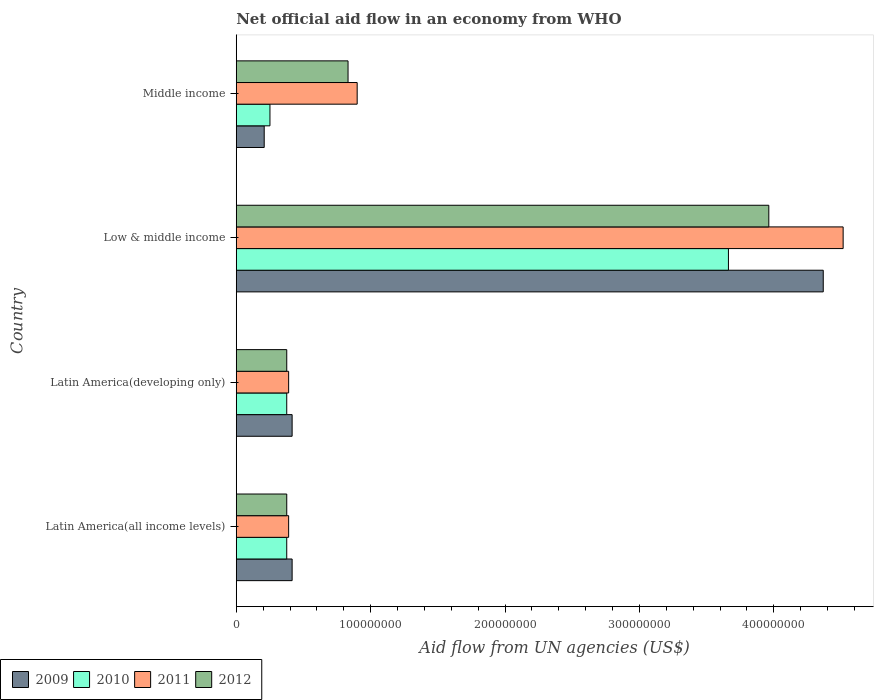How many different coloured bars are there?
Provide a short and direct response. 4. How many groups of bars are there?
Your answer should be very brief. 4. Are the number of bars per tick equal to the number of legend labels?
Keep it short and to the point. Yes. Are the number of bars on each tick of the Y-axis equal?
Keep it short and to the point. Yes. What is the label of the 4th group of bars from the top?
Your answer should be very brief. Latin America(all income levels). In how many cases, is the number of bars for a given country not equal to the number of legend labels?
Make the answer very short. 0. What is the net official aid flow in 2010 in Latin America(all income levels)?
Provide a succinct answer. 3.76e+07. Across all countries, what is the maximum net official aid flow in 2011?
Ensure brevity in your answer.  4.52e+08. Across all countries, what is the minimum net official aid flow in 2009?
Offer a very short reply. 2.08e+07. In which country was the net official aid flow in 2011 minimum?
Your answer should be compact. Latin America(all income levels). What is the total net official aid flow in 2009 in the graph?
Provide a short and direct response. 5.41e+08. What is the difference between the net official aid flow in 2009 in Latin America(all income levels) and that in Low & middle income?
Offer a terse response. -3.95e+08. What is the difference between the net official aid flow in 2009 in Latin America(all income levels) and the net official aid flow in 2010 in Middle income?
Ensure brevity in your answer.  1.65e+07. What is the average net official aid flow in 2011 per country?
Give a very brief answer. 1.55e+08. What is the difference between the net official aid flow in 2011 and net official aid flow in 2010 in Latin America(developing only)?
Give a very brief answer. 1.42e+06. What is the ratio of the net official aid flow in 2011 in Latin America(all income levels) to that in Latin America(developing only)?
Give a very brief answer. 1. Is the net official aid flow in 2010 in Latin America(developing only) less than that in Low & middle income?
Your answer should be very brief. Yes. Is the difference between the net official aid flow in 2011 in Low & middle income and Middle income greater than the difference between the net official aid flow in 2010 in Low & middle income and Middle income?
Your answer should be very brief. Yes. What is the difference between the highest and the second highest net official aid flow in 2009?
Keep it short and to the point. 3.95e+08. What is the difference between the highest and the lowest net official aid flow in 2012?
Ensure brevity in your answer.  3.59e+08. In how many countries, is the net official aid flow in 2009 greater than the average net official aid flow in 2009 taken over all countries?
Ensure brevity in your answer.  1. Is the sum of the net official aid flow in 2012 in Low & middle income and Middle income greater than the maximum net official aid flow in 2010 across all countries?
Keep it short and to the point. Yes. What does the 2nd bar from the bottom in Middle income represents?
Offer a terse response. 2010. How many bars are there?
Keep it short and to the point. 16. Are all the bars in the graph horizontal?
Provide a short and direct response. Yes. What is the difference between two consecutive major ticks on the X-axis?
Give a very brief answer. 1.00e+08. Does the graph contain grids?
Ensure brevity in your answer.  No. Where does the legend appear in the graph?
Ensure brevity in your answer.  Bottom left. What is the title of the graph?
Your answer should be compact. Net official aid flow in an economy from WHO. Does "1980" appear as one of the legend labels in the graph?
Your response must be concise. No. What is the label or title of the X-axis?
Your response must be concise. Aid flow from UN agencies (US$). What is the label or title of the Y-axis?
Make the answer very short. Country. What is the Aid flow from UN agencies (US$) in 2009 in Latin America(all income levels)?
Offer a very short reply. 4.16e+07. What is the Aid flow from UN agencies (US$) of 2010 in Latin America(all income levels)?
Ensure brevity in your answer.  3.76e+07. What is the Aid flow from UN agencies (US$) of 2011 in Latin America(all income levels)?
Your answer should be very brief. 3.90e+07. What is the Aid flow from UN agencies (US$) in 2012 in Latin America(all income levels)?
Offer a terse response. 3.76e+07. What is the Aid flow from UN agencies (US$) in 2009 in Latin America(developing only)?
Your response must be concise. 4.16e+07. What is the Aid flow from UN agencies (US$) in 2010 in Latin America(developing only)?
Ensure brevity in your answer.  3.76e+07. What is the Aid flow from UN agencies (US$) of 2011 in Latin America(developing only)?
Your response must be concise. 3.90e+07. What is the Aid flow from UN agencies (US$) of 2012 in Latin America(developing only)?
Provide a short and direct response. 3.76e+07. What is the Aid flow from UN agencies (US$) in 2009 in Low & middle income?
Your response must be concise. 4.37e+08. What is the Aid flow from UN agencies (US$) of 2010 in Low & middle income?
Provide a succinct answer. 3.66e+08. What is the Aid flow from UN agencies (US$) of 2011 in Low & middle income?
Keep it short and to the point. 4.52e+08. What is the Aid flow from UN agencies (US$) in 2012 in Low & middle income?
Offer a very short reply. 3.96e+08. What is the Aid flow from UN agencies (US$) in 2009 in Middle income?
Give a very brief answer. 2.08e+07. What is the Aid flow from UN agencies (US$) in 2010 in Middle income?
Your answer should be very brief. 2.51e+07. What is the Aid flow from UN agencies (US$) in 2011 in Middle income?
Give a very brief answer. 9.00e+07. What is the Aid flow from UN agencies (US$) of 2012 in Middle income?
Offer a very short reply. 8.32e+07. Across all countries, what is the maximum Aid flow from UN agencies (US$) in 2009?
Provide a succinct answer. 4.37e+08. Across all countries, what is the maximum Aid flow from UN agencies (US$) of 2010?
Give a very brief answer. 3.66e+08. Across all countries, what is the maximum Aid flow from UN agencies (US$) in 2011?
Offer a very short reply. 4.52e+08. Across all countries, what is the maximum Aid flow from UN agencies (US$) in 2012?
Offer a terse response. 3.96e+08. Across all countries, what is the minimum Aid flow from UN agencies (US$) of 2009?
Provide a short and direct response. 2.08e+07. Across all countries, what is the minimum Aid flow from UN agencies (US$) in 2010?
Make the answer very short. 2.51e+07. Across all countries, what is the minimum Aid flow from UN agencies (US$) in 2011?
Make the answer very short. 3.90e+07. Across all countries, what is the minimum Aid flow from UN agencies (US$) in 2012?
Your answer should be very brief. 3.76e+07. What is the total Aid flow from UN agencies (US$) in 2009 in the graph?
Your response must be concise. 5.41e+08. What is the total Aid flow from UN agencies (US$) of 2010 in the graph?
Your answer should be compact. 4.66e+08. What is the total Aid flow from UN agencies (US$) in 2011 in the graph?
Keep it short and to the point. 6.20e+08. What is the total Aid flow from UN agencies (US$) of 2012 in the graph?
Give a very brief answer. 5.55e+08. What is the difference between the Aid flow from UN agencies (US$) of 2009 in Latin America(all income levels) and that in Latin America(developing only)?
Keep it short and to the point. 0. What is the difference between the Aid flow from UN agencies (US$) of 2010 in Latin America(all income levels) and that in Latin America(developing only)?
Your answer should be compact. 0. What is the difference between the Aid flow from UN agencies (US$) of 2009 in Latin America(all income levels) and that in Low & middle income?
Your response must be concise. -3.95e+08. What is the difference between the Aid flow from UN agencies (US$) in 2010 in Latin America(all income levels) and that in Low & middle income?
Offer a very short reply. -3.29e+08. What is the difference between the Aid flow from UN agencies (US$) of 2011 in Latin America(all income levels) and that in Low & middle income?
Keep it short and to the point. -4.13e+08. What is the difference between the Aid flow from UN agencies (US$) of 2012 in Latin America(all income levels) and that in Low & middle income?
Give a very brief answer. -3.59e+08. What is the difference between the Aid flow from UN agencies (US$) of 2009 in Latin America(all income levels) and that in Middle income?
Give a very brief answer. 2.08e+07. What is the difference between the Aid flow from UN agencies (US$) in 2010 in Latin America(all income levels) and that in Middle income?
Ensure brevity in your answer.  1.25e+07. What is the difference between the Aid flow from UN agencies (US$) of 2011 in Latin America(all income levels) and that in Middle income?
Make the answer very short. -5.10e+07. What is the difference between the Aid flow from UN agencies (US$) in 2012 in Latin America(all income levels) and that in Middle income?
Ensure brevity in your answer.  -4.56e+07. What is the difference between the Aid flow from UN agencies (US$) in 2009 in Latin America(developing only) and that in Low & middle income?
Your response must be concise. -3.95e+08. What is the difference between the Aid flow from UN agencies (US$) of 2010 in Latin America(developing only) and that in Low & middle income?
Provide a short and direct response. -3.29e+08. What is the difference between the Aid flow from UN agencies (US$) of 2011 in Latin America(developing only) and that in Low & middle income?
Your answer should be very brief. -4.13e+08. What is the difference between the Aid flow from UN agencies (US$) in 2012 in Latin America(developing only) and that in Low & middle income?
Make the answer very short. -3.59e+08. What is the difference between the Aid flow from UN agencies (US$) in 2009 in Latin America(developing only) and that in Middle income?
Ensure brevity in your answer.  2.08e+07. What is the difference between the Aid flow from UN agencies (US$) of 2010 in Latin America(developing only) and that in Middle income?
Offer a terse response. 1.25e+07. What is the difference between the Aid flow from UN agencies (US$) of 2011 in Latin America(developing only) and that in Middle income?
Ensure brevity in your answer.  -5.10e+07. What is the difference between the Aid flow from UN agencies (US$) in 2012 in Latin America(developing only) and that in Middle income?
Keep it short and to the point. -4.56e+07. What is the difference between the Aid flow from UN agencies (US$) of 2009 in Low & middle income and that in Middle income?
Offer a terse response. 4.16e+08. What is the difference between the Aid flow from UN agencies (US$) in 2010 in Low & middle income and that in Middle income?
Keep it short and to the point. 3.41e+08. What is the difference between the Aid flow from UN agencies (US$) in 2011 in Low & middle income and that in Middle income?
Your answer should be compact. 3.62e+08. What is the difference between the Aid flow from UN agencies (US$) in 2012 in Low & middle income and that in Middle income?
Ensure brevity in your answer.  3.13e+08. What is the difference between the Aid flow from UN agencies (US$) in 2009 in Latin America(all income levels) and the Aid flow from UN agencies (US$) in 2010 in Latin America(developing only)?
Offer a terse response. 4.01e+06. What is the difference between the Aid flow from UN agencies (US$) in 2009 in Latin America(all income levels) and the Aid flow from UN agencies (US$) in 2011 in Latin America(developing only)?
Make the answer very short. 2.59e+06. What is the difference between the Aid flow from UN agencies (US$) in 2009 in Latin America(all income levels) and the Aid flow from UN agencies (US$) in 2012 in Latin America(developing only)?
Offer a terse response. 3.99e+06. What is the difference between the Aid flow from UN agencies (US$) in 2010 in Latin America(all income levels) and the Aid flow from UN agencies (US$) in 2011 in Latin America(developing only)?
Offer a terse response. -1.42e+06. What is the difference between the Aid flow from UN agencies (US$) of 2010 in Latin America(all income levels) and the Aid flow from UN agencies (US$) of 2012 in Latin America(developing only)?
Your answer should be very brief. -2.00e+04. What is the difference between the Aid flow from UN agencies (US$) in 2011 in Latin America(all income levels) and the Aid flow from UN agencies (US$) in 2012 in Latin America(developing only)?
Your response must be concise. 1.40e+06. What is the difference between the Aid flow from UN agencies (US$) in 2009 in Latin America(all income levels) and the Aid flow from UN agencies (US$) in 2010 in Low & middle income?
Keep it short and to the point. -3.25e+08. What is the difference between the Aid flow from UN agencies (US$) in 2009 in Latin America(all income levels) and the Aid flow from UN agencies (US$) in 2011 in Low & middle income?
Your answer should be compact. -4.10e+08. What is the difference between the Aid flow from UN agencies (US$) in 2009 in Latin America(all income levels) and the Aid flow from UN agencies (US$) in 2012 in Low & middle income?
Your answer should be very brief. -3.55e+08. What is the difference between the Aid flow from UN agencies (US$) of 2010 in Latin America(all income levels) and the Aid flow from UN agencies (US$) of 2011 in Low & middle income?
Offer a terse response. -4.14e+08. What is the difference between the Aid flow from UN agencies (US$) of 2010 in Latin America(all income levels) and the Aid flow from UN agencies (US$) of 2012 in Low & middle income?
Keep it short and to the point. -3.59e+08. What is the difference between the Aid flow from UN agencies (US$) of 2011 in Latin America(all income levels) and the Aid flow from UN agencies (US$) of 2012 in Low & middle income?
Provide a succinct answer. -3.57e+08. What is the difference between the Aid flow from UN agencies (US$) of 2009 in Latin America(all income levels) and the Aid flow from UN agencies (US$) of 2010 in Middle income?
Offer a terse response. 1.65e+07. What is the difference between the Aid flow from UN agencies (US$) of 2009 in Latin America(all income levels) and the Aid flow from UN agencies (US$) of 2011 in Middle income?
Ensure brevity in your answer.  -4.84e+07. What is the difference between the Aid flow from UN agencies (US$) of 2009 in Latin America(all income levels) and the Aid flow from UN agencies (US$) of 2012 in Middle income?
Your response must be concise. -4.16e+07. What is the difference between the Aid flow from UN agencies (US$) of 2010 in Latin America(all income levels) and the Aid flow from UN agencies (US$) of 2011 in Middle income?
Your response must be concise. -5.24e+07. What is the difference between the Aid flow from UN agencies (US$) in 2010 in Latin America(all income levels) and the Aid flow from UN agencies (US$) in 2012 in Middle income?
Your response must be concise. -4.56e+07. What is the difference between the Aid flow from UN agencies (US$) of 2011 in Latin America(all income levels) and the Aid flow from UN agencies (US$) of 2012 in Middle income?
Ensure brevity in your answer.  -4.42e+07. What is the difference between the Aid flow from UN agencies (US$) of 2009 in Latin America(developing only) and the Aid flow from UN agencies (US$) of 2010 in Low & middle income?
Offer a very short reply. -3.25e+08. What is the difference between the Aid flow from UN agencies (US$) of 2009 in Latin America(developing only) and the Aid flow from UN agencies (US$) of 2011 in Low & middle income?
Ensure brevity in your answer.  -4.10e+08. What is the difference between the Aid flow from UN agencies (US$) in 2009 in Latin America(developing only) and the Aid flow from UN agencies (US$) in 2012 in Low & middle income?
Keep it short and to the point. -3.55e+08. What is the difference between the Aid flow from UN agencies (US$) in 2010 in Latin America(developing only) and the Aid flow from UN agencies (US$) in 2011 in Low & middle income?
Offer a terse response. -4.14e+08. What is the difference between the Aid flow from UN agencies (US$) in 2010 in Latin America(developing only) and the Aid flow from UN agencies (US$) in 2012 in Low & middle income?
Offer a terse response. -3.59e+08. What is the difference between the Aid flow from UN agencies (US$) in 2011 in Latin America(developing only) and the Aid flow from UN agencies (US$) in 2012 in Low & middle income?
Your response must be concise. -3.57e+08. What is the difference between the Aid flow from UN agencies (US$) in 2009 in Latin America(developing only) and the Aid flow from UN agencies (US$) in 2010 in Middle income?
Your answer should be very brief. 1.65e+07. What is the difference between the Aid flow from UN agencies (US$) in 2009 in Latin America(developing only) and the Aid flow from UN agencies (US$) in 2011 in Middle income?
Your answer should be very brief. -4.84e+07. What is the difference between the Aid flow from UN agencies (US$) in 2009 in Latin America(developing only) and the Aid flow from UN agencies (US$) in 2012 in Middle income?
Provide a short and direct response. -4.16e+07. What is the difference between the Aid flow from UN agencies (US$) of 2010 in Latin America(developing only) and the Aid flow from UN agencies (US$) of 2011 in Middle income?
Your response must be concise. -5.24e+07. What is the difference between the Aid flow from UN agencies (US$) of 2010 in Latin America(developing only) and the Aid flow from UN agencies (US$) of 2012 in Middle income?
Offer a terse response. -4.56e+07. What is the difference between the Aid flow from UN agencies (US$) in 2011 in Latin America(developing only) and the Aid flow from UN agencies (US$) in 2012 in Middle income?
Your answer should be compact. -4.42e+07. What is the difference between the Aid flow from UN agencies (US$) of 2009 in Low & middle income and the Aid flow from UN agencies (US$) of 2010 in Middle income?
Make the answer very short. 4.12e+08. What is the difference between the Aid flow from UN agencies (US$) of 2009 in Low & middle income and the Aid flow from UN agencies (US$) of 2011 in Middle income?
Make the answer very short. 3.47e+08. What is the difference between the Aid flow from UN agencies (US$) of 2009 in Low & middle income and the Aid flow from UN agencies (US$) of 2012 in Middle income?
Offer a terse response. 3.54e+08. What is the difference between the Aid flow from UN agencies (US$) in 2010 in Low & middle income and the Aid flow from UN agencies (US$) in 2011 in Middle income?
Your answer should be compact. 2.76e+08. What is the difference between the Aid flow from UN agencies (US$) in 2010 in Low & middle income and the Aid flow from UN agencies (US$) in 2012 in Middle income?
Provide a short and direct response. 2.83e+08. What is the difference between the Aid flow from UN agencies (US$) in 2011 in Low & middle income and the Aid flow from UN agencies (US$) in 2012 in Middle income?
Offer a very short reply. 3.68e+08. What is the average Aid flow from UN agencies (US$) in 2009 per country?
Offer a terse response. 1.35e+08. What is the average Aid flow from UN agencies (US$) in 2010 per country?
Provide a succinct answer. 1.17e+08. What is the average Aid flow from UN agencies (US$) in 2011 per country?
Provide a succinct answer. 1.55e+08. What is the average Aid flow from UN agencies (US$) in 2012 per country?
Ensure brevity in your answer.  1.39e+08. What is the difference between the Aid flow from UN agencies (US$) in 2009 and Aid flow from UN agencies (US$) in 2010 in Latin America(all income levels)?
Keep it short and to the point. 4.01e+06. What is the difference between the Aid flow from UN agencies (US$) of 2009 and Aid flow from UN agencies (US$) of 2011 in Latin America(all income levels)?
Offer a very short reply. 2.59e+06. What is the difference between the Aid flow from UN agencies (US$) of 2009 and Aid flow from UN agencies (US$) of 2012 in Latin America(all income levels)?
Keep it short and to the point. 3.99e+06. What is the difference between the Aid flow from UN agencies (US$) of 2010 and Aid flow from UN agencies (US$) of 2011 in Latin America(all income levels)?
Your answer should be compact. -1.42e+06. What is the difference between the Aid flow from UN agencies (US$) in 2010 and Aid flow from UN agencies (US$) in 2012 in Latin America(all income levels)?
Your answer should be very brief. -2.00e+04. What is the difference between the Aid flow from UN agencies (US$) in 2011 and Aid flow from UN agencies (US$) in 2012 in Latin America(all income levels)?
Ensure brevity in your answer.  1.40e+06. What is the difference between the Aid flow from UN agencies (US$) in 2009 and Aid flow from UN agencies (US$) in 2010 in Latin America(developing only)?
Provide a succinct answer. 4.01e+06. What is the difference between the Aid flow from UN agencies (US$) in 2009 and Aid flow from UN agencies (US$) in 2011 in Latin America(developing only)?
Provide a succinct answer. 2.59e+06. What is the difference between the Aid flow from UN agencies (US$) of 2009 and Aid flow from UN agencies (US$) of 2012 in Latin America(developing only)?
Ensure brevity in your answer.  3.99e+06. What is the difference between the Aid flow from UN agencies (US$) in 2010 and Aid flow from UN agencies (US$) in 2011 in Latin America(developing only)?
Provide a short and direct response. -1.42e+06. What is the difference between the Aid flow from UN agencies (US$) in 2011 and Aid flow from UN agencies (US$) in 2012 in Latin America(developing only)?
Give a very brief answer. 1.40e+06. What is the difference between the Aid flow from UN agencies (US$) in 2009 and Aid flow from UN agencies (US$) in 2010 in Low & middle income?
Make the answer very short. 7.06e+07. What is the difference between the Aid flow from UN agencies (US$) of 2009 and Aid flow from UN agencies (US$) of 2011 in Low & middle income?
Your answer should be compact. -1.48e+07. What is the difference between the Aid flow from UN agencies (US$) of 2009 and Aid flow from UN agencies (US$) of 2012 in Low & middle income?
Your answer should be compact. 4.05e+07. What is the difference between the Aid flow from UN agencies (US$) of 2010 and Aid flow from UN agencies (US$) of 2011 in Low & middle income?
Your answer should be very brief. -8.54e+07. What is the difference between the Aid flow from UN agencies (US$) of 2010 and Aid flow from UN agencies (US$) of 2012 in Low & middle income?
Keep it short and to the point. -3.00e+07. What is the difference between the Aid flow from UN agencies (US$) of 2011 and Aid flow from UN agencies (US$) of 2012 in Low & middle income?
Provide a succinct answer. 5.53e+07. What is the difference between the Aid flow from UN agencies (US$) in 2009 and Aid flow from UN agencies (US$) in 2010 in Middle income?
Make the answer very short. -4.27e+06. What is the difference between the Aid flow from UN agencies (US$) in 2009 and Aid flow from UN agencies (US$) in 2011 in Middle income?
Offer a very short reply. -6.92e+07. What is the difference between the Aid flow from UN agencies (US$) in 2009 and Aid flow from UN agencies (US$) in 2012 in Middle income?
Provide a short and direct response. -6.24e+07. What is the difference between the Aid flow from UN agencies (US$) in 2010 and Aid flow from UN agencies (US$) in 2011 in Middle income?
Keep it short and to the point. -6.49e+07. What is the difference between the Aid flow from UN agencies (US$) in 2010 and Aid flow from UN agencies (US$) in 2012 in Middle income?
Your response must be concise. -5.81e+07. What is the difference between the Aid flow from UN agencies (US$) in 2011 and Aid flow from UN agencies (US$) in 2012 in Middle income?
Your response must be concise. 6.80e+06. What is the ratio of the Aid flow from UN agencies (US$) in 2009 in Latin America(all income levels) to that in Low & middle income?
Your response must be concise. 0.1. What is the ratio of the Aid flow from UN agencies (US$) of 2010 in Latin America(all income levels) to that in Low & middle income?
Ensure brevity in your answer.  0.1. What is the ratio of the Aid flow from UN agencies (US$) of 2011 in Latin America(all income levels) to that in Low & middle income?
Your answer should be very brief. 0.09. What is the ratio of the Aid flow from UN agencies (US$) of 2012 in Latin America(all income levels) to that in Low & middle income?
Keep it short and to the point. 0.09. What is the ratio of the Aid flow from UN agencies (US$) in 2009 in Latin America(all income levels) to that in Middle income?
Give a very brief answer. 2. What is the ratio of the Aid flow from UN agencies (US$) of 2010 in Latin America(all income levels) to that in Middle income?
Offer a very short reply. 1.5. What is the ratio of the Aid flow from UN agencies (US$) in 2011 in Latin America(all income levels) to that in Middle income?
Offer a terse response. 0.43. What is the ratio of the Aid flow from UN agencies (US$) in 2012 in Latin America(all income levels) to that in Middle income?
Your answer should be compact. 0.45. What is the ratio of the Aid flow from UN agencies (US$) in 2009 in Latin America(developing only) to that in Low & middle income?
Your response must be concise. 0.1. What is the ratio of the Aid flow from UN agencies (US$) in 2010 in Latin America(developing only) to that in Low & middle income?
Offer a terse response. 0.1. What is the ratio of the Aid flow from UN agencies (US$) of 2011 in Latin America(developing only) to that in Low & middle income?
Offer a terse response. 0.09. What is the ratio of the Aid flow from UN agencies (US$) in 2012 in Latin America(developing only) to that in Low & middle income?
Ensure brevity in your answer.  0.09. What is the ratio of the Aid flow from UN agencies (US$) of 2009 in Latin America(developing only) to that in Middle income?
Your response must be concise. 2. What is the ratio of the Aid flow from UN agencies (US$) in 2010 in Latin America(developing only) to that in Middle income?
Your response must be concise. 1.5. What is the ratio of the Aid flow from UN agencies (US$) of 2011 in Latin America(developing only) to that in Middle income?
Your answer should be compact. 0.43. What is the ratio of the Aid flow from UN agencies (US$) of 2012 in Latin America(developing only) to that in Middle income?
Give a very brief answer. 0.45. What is the ratio of the Aid flow from UN agencies (US$) in 2009 in Low & middle income to that in Middle income?
Offer a terse response. 21. What is the ratio of the Aid flow from UN agencies (US$) in 2010 in Low & middle income to that in Middle income?
Keep it short and to the point. 14.61. What is the ratio of the Aid flow from UN agencies (US$) in 2011 in Low & middle income to that in Middle income?
Offer a very short reply. 5.02. What is the ratio of the Aid flow from UN agencies (US$) in 2012 in Low & middle income to that in Middle income?
Your answer should be very brief. 4.76. What is the difference between the highest and the second highest Aid flow from UN agencies (US$) of 2009?
Your answer should be very brief. 3.95e+08. What is the difference between the highest and the second highest Aid flow from UN agencies (US$) of 2010?
Offer a terse response. 3.29e+08. What is the difference between the highest and the second highest Aid flow from UN agencies (US$) in 2011?
Ensure brevity in your answer.  3.62e+08. What is the difference between the highest and the second highest Aid flow from UN agencies (US$) in 2012?
Make the answer very short. 3.13e+08. What is the difference between the highest and the lowest Aid flow from UN agencies (US$) of 2009?
Give a very brief answer. 4.16e+08. What is the difference between the highest and the lowest Aid flow from UN agencies (US$) in 2010?
Make the answer very short. 3.41e+08. What is the difference between the highest and the lowest Aid flow from UN agencies (US$) in 2011?
Ensure brevity in your answer.  4.13e+08. What is the difference between the highest and the lowest Aid flow from UN agencies (US$) of 2012?
Your answer should be very brief. 3.59e+08. 